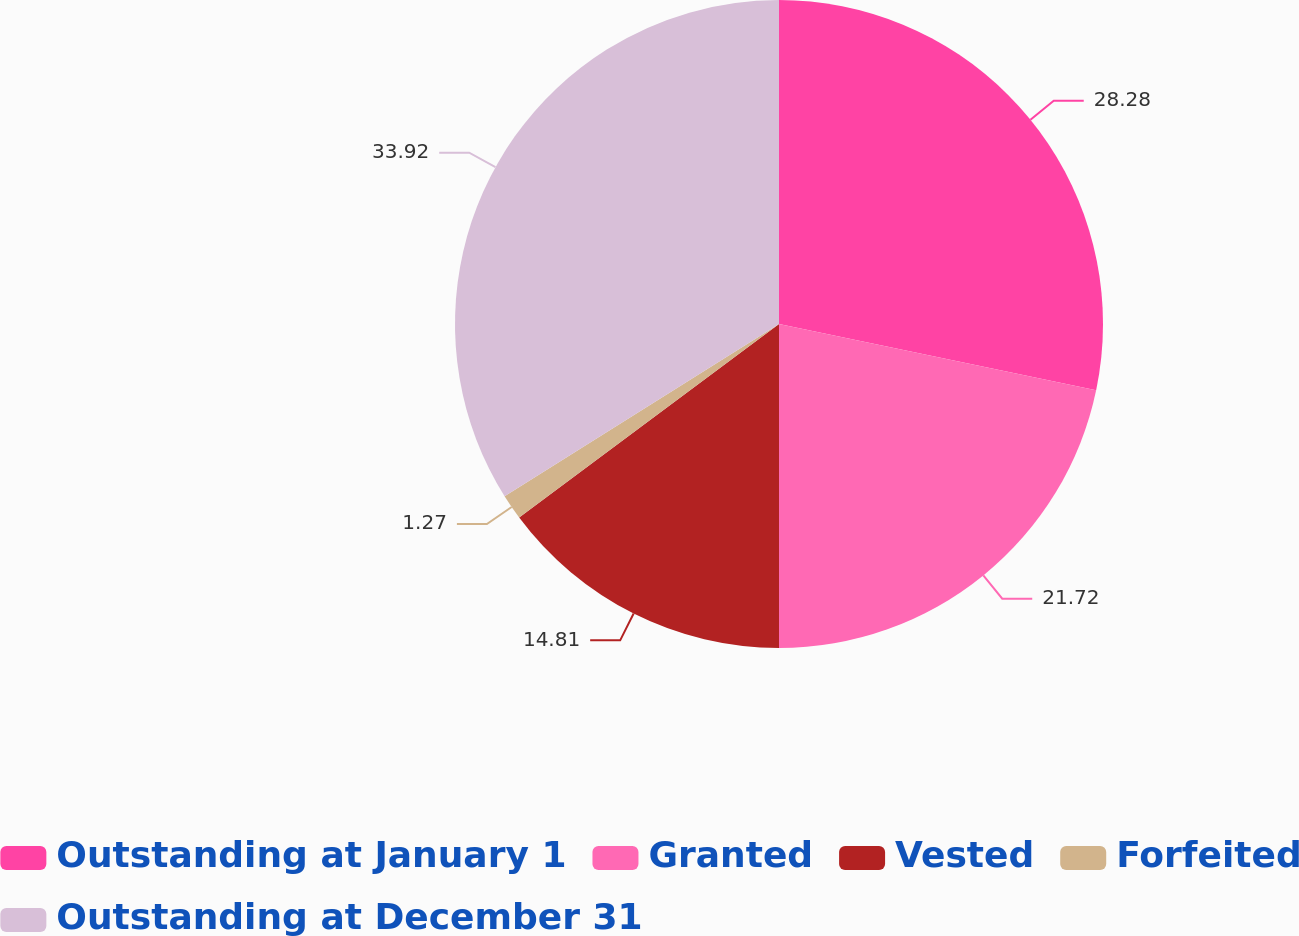Convert chart to OTSL. <chart><loc_0><loc_0><loc_500><loc_500><pie_chart><fcel>Outstanding at January 1<fcel>Granted<fcel>Vested<fcel>Forfeited<fcel>Outstanding at December 31<nl><fcel>28.28%<fcel>21.72%<fcel>14.81%<fcel>1.27%<fcel>33.92%<nl></chart> 